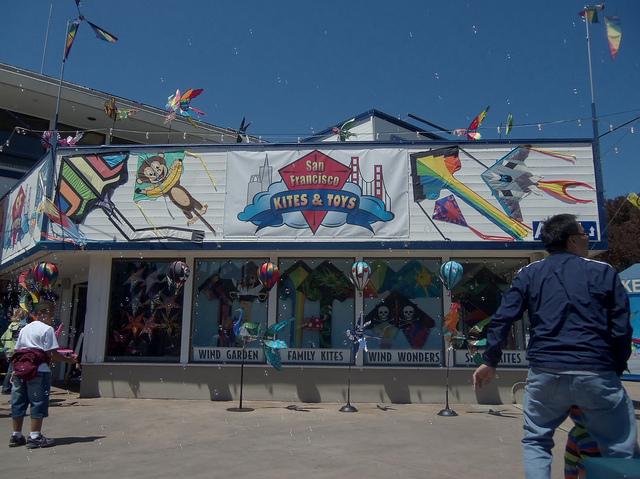Where is this business likely located?
Concise answer only. San francisco. What language is the sign in?
Quick response, please. English. Does the sign say corn dogs?
Be succinct. No. How many windows  on the building are visible in the photo?
Write a very short answer. 1. What color is his shirt?
Be succinct. Blue. What animal is in the banner?
Answer briefly. Monkey. What ethnicity is the person in the blue shirt?
Answer briefly. White. What is the name of the business?
Answer briefly. Kites & toys. What is the business?
Be succinct. Kites and toys. Is the guy in the front shirtless?
Write a very short answer. No. Does the store sell kites?
Keep it brief. Yes. Has it recently snowed?
Be succinct. No. Is it a sunny or a rain day?
Answer briefly. Sunny. What is the color of the girls jacket?
Answer briefly. Red. Is there a person with gray hair in the picture?
Quick response, please. No. What is this boy about to do?
Quick response, please. Fly kite. 